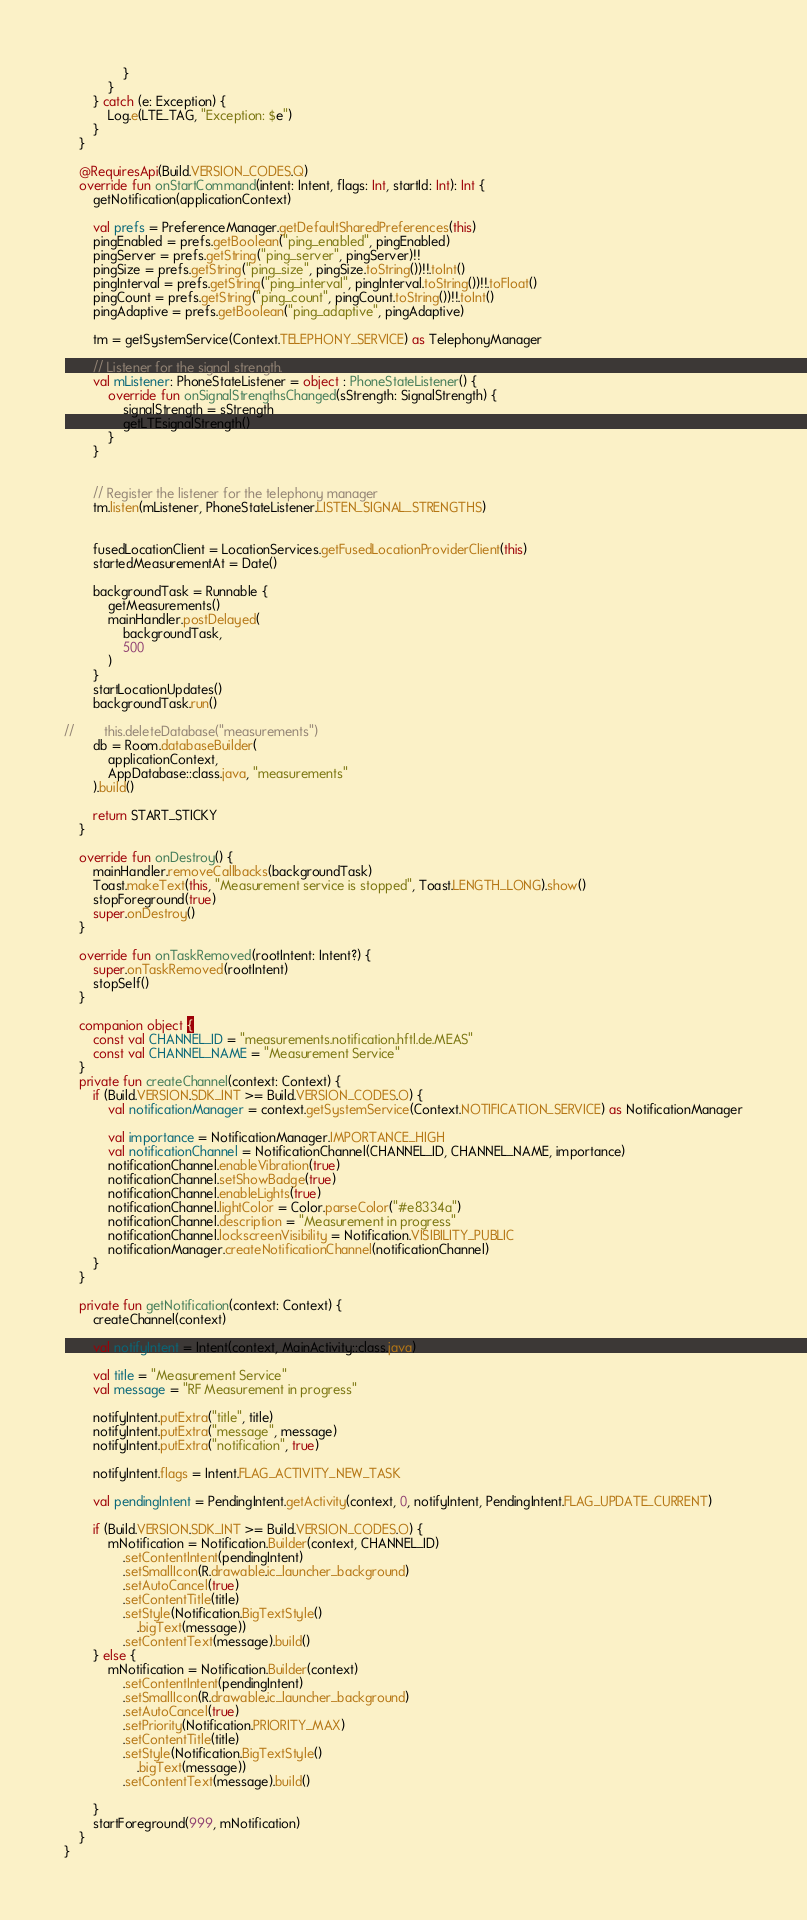Convert code to text. <code><loc_0><loc_0><loc_500><loc_500><_Kotlin_>                }
            }
        } catch (e: Exception) {
            Log.e(LTE_TAG, "Exception: $e")
        }
    }

    @RequiresApi(Build.VERSION_CODES.Q)
    override fun onStartCommand(intent: Intent, flags: Int, startId: Int): Int {
        getNotification(applicationContext)

        val prefs = PreferenceManager.getDefaultSharedPreferences(this)
        pingEnabled = prefs.getBoolean("ping_enabled", pingEnabled)
        pingServer = prefs.getString("ping_server", pingServer)!!
        pingSize = prefs.getString("ping_size", pingSize.toString())!!.toInt()
        pingInterval = prefs.getString("ping_interval", pingInterval.toString())!!.toFloat()
        pingCount = prefs.getString("ping_count", pingCount.toString())!!.toInt()
        pingAdaptive = prefs.getBoolean("ping_adaptive", pingAdaptive)

        tm = getSystemService(Context.TELEPHONY_SERVICE) as TelephonyManager

        // Listener for the signal strength.
        val mListener: PhoneStateListener = object : PhoneStateListener() {
            override fun onSignalStrengthsChanged(sStrength: SignalStrength) {
                signalStrength = sStrength
                getLTEsignalStrength()
            }
        }


        // Register the listener for the telephony manager
        tm.listen(mListener, PhoneStateListener.LISTEN_SIGNAL_STRENGTHS)


        fusedLocationClient = LocationServices.getFusedLocationProviderClient(this)
        startedMeasurementAt = Date()

        backgroundTask = Runnable {
            getMeasurements()
            mainHandler.postDelayed(
                backgroundTask,
                500
            )
        }
        startLocationUpdates()
        backgroundTask.run()

//        this.deleteDatabase("measurements")
        db = Room.databaseBuilder(
            applicationContext,
            AppDatabase::class.java, "measurements"
        ).build()

        return START_STICKY
    }

    override fun onDestroy() {
        mainHandler.removeCallbacks(backgroundTask)
        Toast.makeText(this, "Measurement service is stopped", Toast.LENGTH_LONG).show()
        stopForeground(true)
        super.onDestroy()
    }

    override fun onTaskRemoved(rootIntent: Intent?) {
        super.onTaskRemoved(rootIntent)
        stopSelf()
    }

    companion object {
        const val CHANNEL_ID = "measurements.notification.hftl.de.MEAS"
        const val CHANNEL_NAME = "Measurement Service"
    }
    private fun createChannel(context: Context) {
        if (Build.VERSION.SDK_INT >= Build.VERSION_CODES.O) {
            val notificationManager = context.getSystemService(Context.NOTIFICATION_SERVICE) as NotificationManager

            val importance = NotificationManager.IMPORTANCE_HIGH
            val notificationChannel = NotificationChannel(CHANNEL_ID, CHANNEL_NAME, importance)
            notificationChannel.enableVibration(true)
            notificationChannel.setShowBadge(true)
            notificationChannel.enableLights(true)
            notificationChannel.lightColor = Color.parseColor("#e8334a")
            notificationChannel.description = "Measurement in progress"
            notificationChannel.lockscreenVisibility = Notification.VISIBILITY_PUBLIC
            notificationManager.createNotificationChannel(notificationChannel)
        }
    }

    private fun getNotification(context: Context) {
        createChannel(context)

        val notifyIntent = Intent(context, MainActivity::class.java)

        val title = "Measurement Service"
        val message = "RF Measurement in progress"

        notifyIntent.putExtra("title", title)
        notifyIntent.putExtra("message", message)
        notifyIntent.putExtra("notification", true)

        notifyIntent.flags = Intent.FLAG_ACTIVITY_NEW_TASK

        val pendingIntent = PendingIntent.getActivity(context, 0, notifyIntent, PendingIntent.FLAG_UPDATE_CURRENT)

        if (Build.VERSION.SDK_INT >= Build.VERSION_CODES.O) {
            mNotification = Notification.Builder(context, CHANNEL_ID)
                .setContentIntent(pendingIntent)
                .setSmallIcon(R.drawable.ic_launcher_background)
                .setAutoCancel(true)
                .setContentTitle(title)
                .setStyle(Notification.BigTextStyle()
                    .bigText(message))
                .setContentText(message).build()
        } else {
            mNotification = Notification.Builder(context)
                .setContentIntent(pendingIntent)
                .setSmallIcon(R.drawable.ic_launcher_background)
                .setAutoCancel(true)
                .setPriority(Notification.PRIORITY_MAX)
                .setContentTitle(title)
                .setStyle(Notification.BigTextStyle()
                    .bigText(message))
                .setContentText(message).build()

        }
        startForeground(999, mNotification)
    }
}</code> 